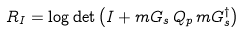<formula> <loc_0><loc_0><loc_500><loc_500>R _ { I } = \log \det \left ( I + m { G } _ { s } \, Q _ { p } \, m { G } _ { s } ^ { \dag } \right )</formula> 